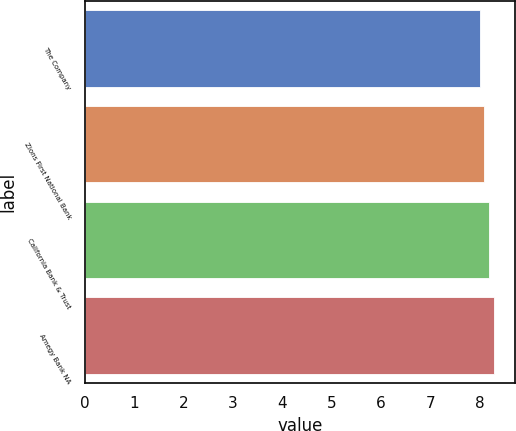<chart> <loc_0><loc_0><loc_500><loc_500><bar_chart><fcel>The Company<fcel>Zions First National Bank<fcel>California Bank & Trust<fcel>Amegy Bank NA<nl><fcel>8<fcel>8.1<fcel>8.2<fcel>8.3<nl></chart> 